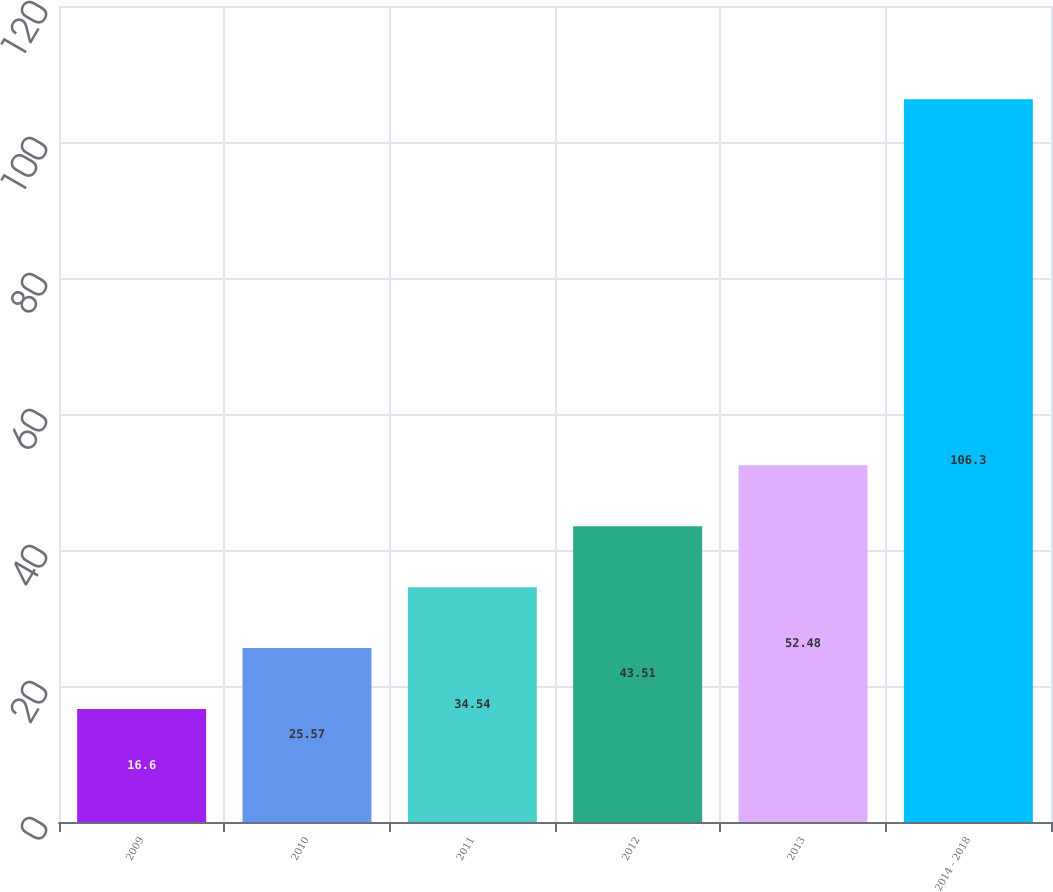Convert chart to OTSL. <chart><loc_0><loc_0><loc_500><loc_500><bar_chart><fcel>2009<fcel>2010<fcel>2011<fcel>2012<fcel>2013<fcel>2014 - 2018<nl><fcel>16.6<fcel>25.57<fcel>34.54<fcel>43.51<fcel>52.48<fcel>106.3<nl></chart> 